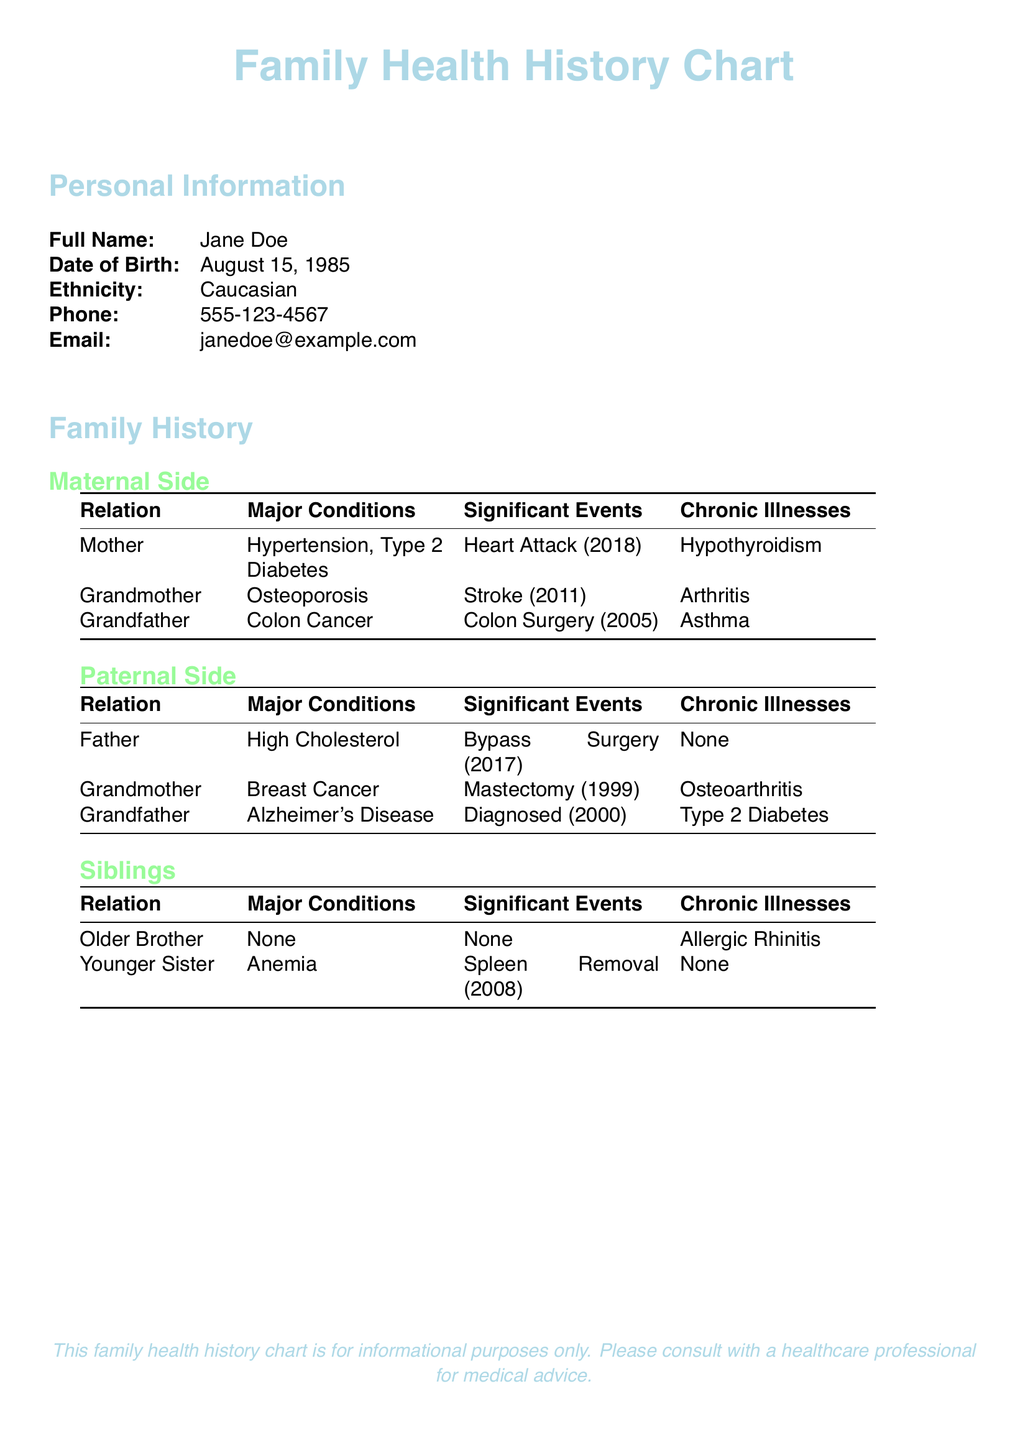What is the full name of the individual? The full name of the individual is listed in the Personal Information section of the document.
Answer: Jane Doe What is the date of birth of the individual? The date of birth can be found in the Personal Information section of the document.
Answer: August 15, 1985 What major condition does the individual's mother have? The major conditions for the individual's family can be found in the Family History section.
Answer: Hypertension, Type 2 Diabetes What significant event is noted for the individual's grandmother on the maternal side? Significant events are listed in the Family History section under the maternal side.
Answer: Stroke (2011) How many siblings does the individual have? The Siblings section indicates the number of siblings present in the family history.
Answer: 2 What chronic illness is noted for the individual's younger sister? The chronic illnesses for the siblings can be found in the Siblings section.
Answer: None What is a major condition of the individual's paternal grandfather? Major conditions for paternal family members are listed in the Family History section.
Answer: Alzheimer's Disease What significant event is listed for the individual's father? Significant events for paternal family members are also included in the Family History section.
Answer: Bypass Surgery (2017) 